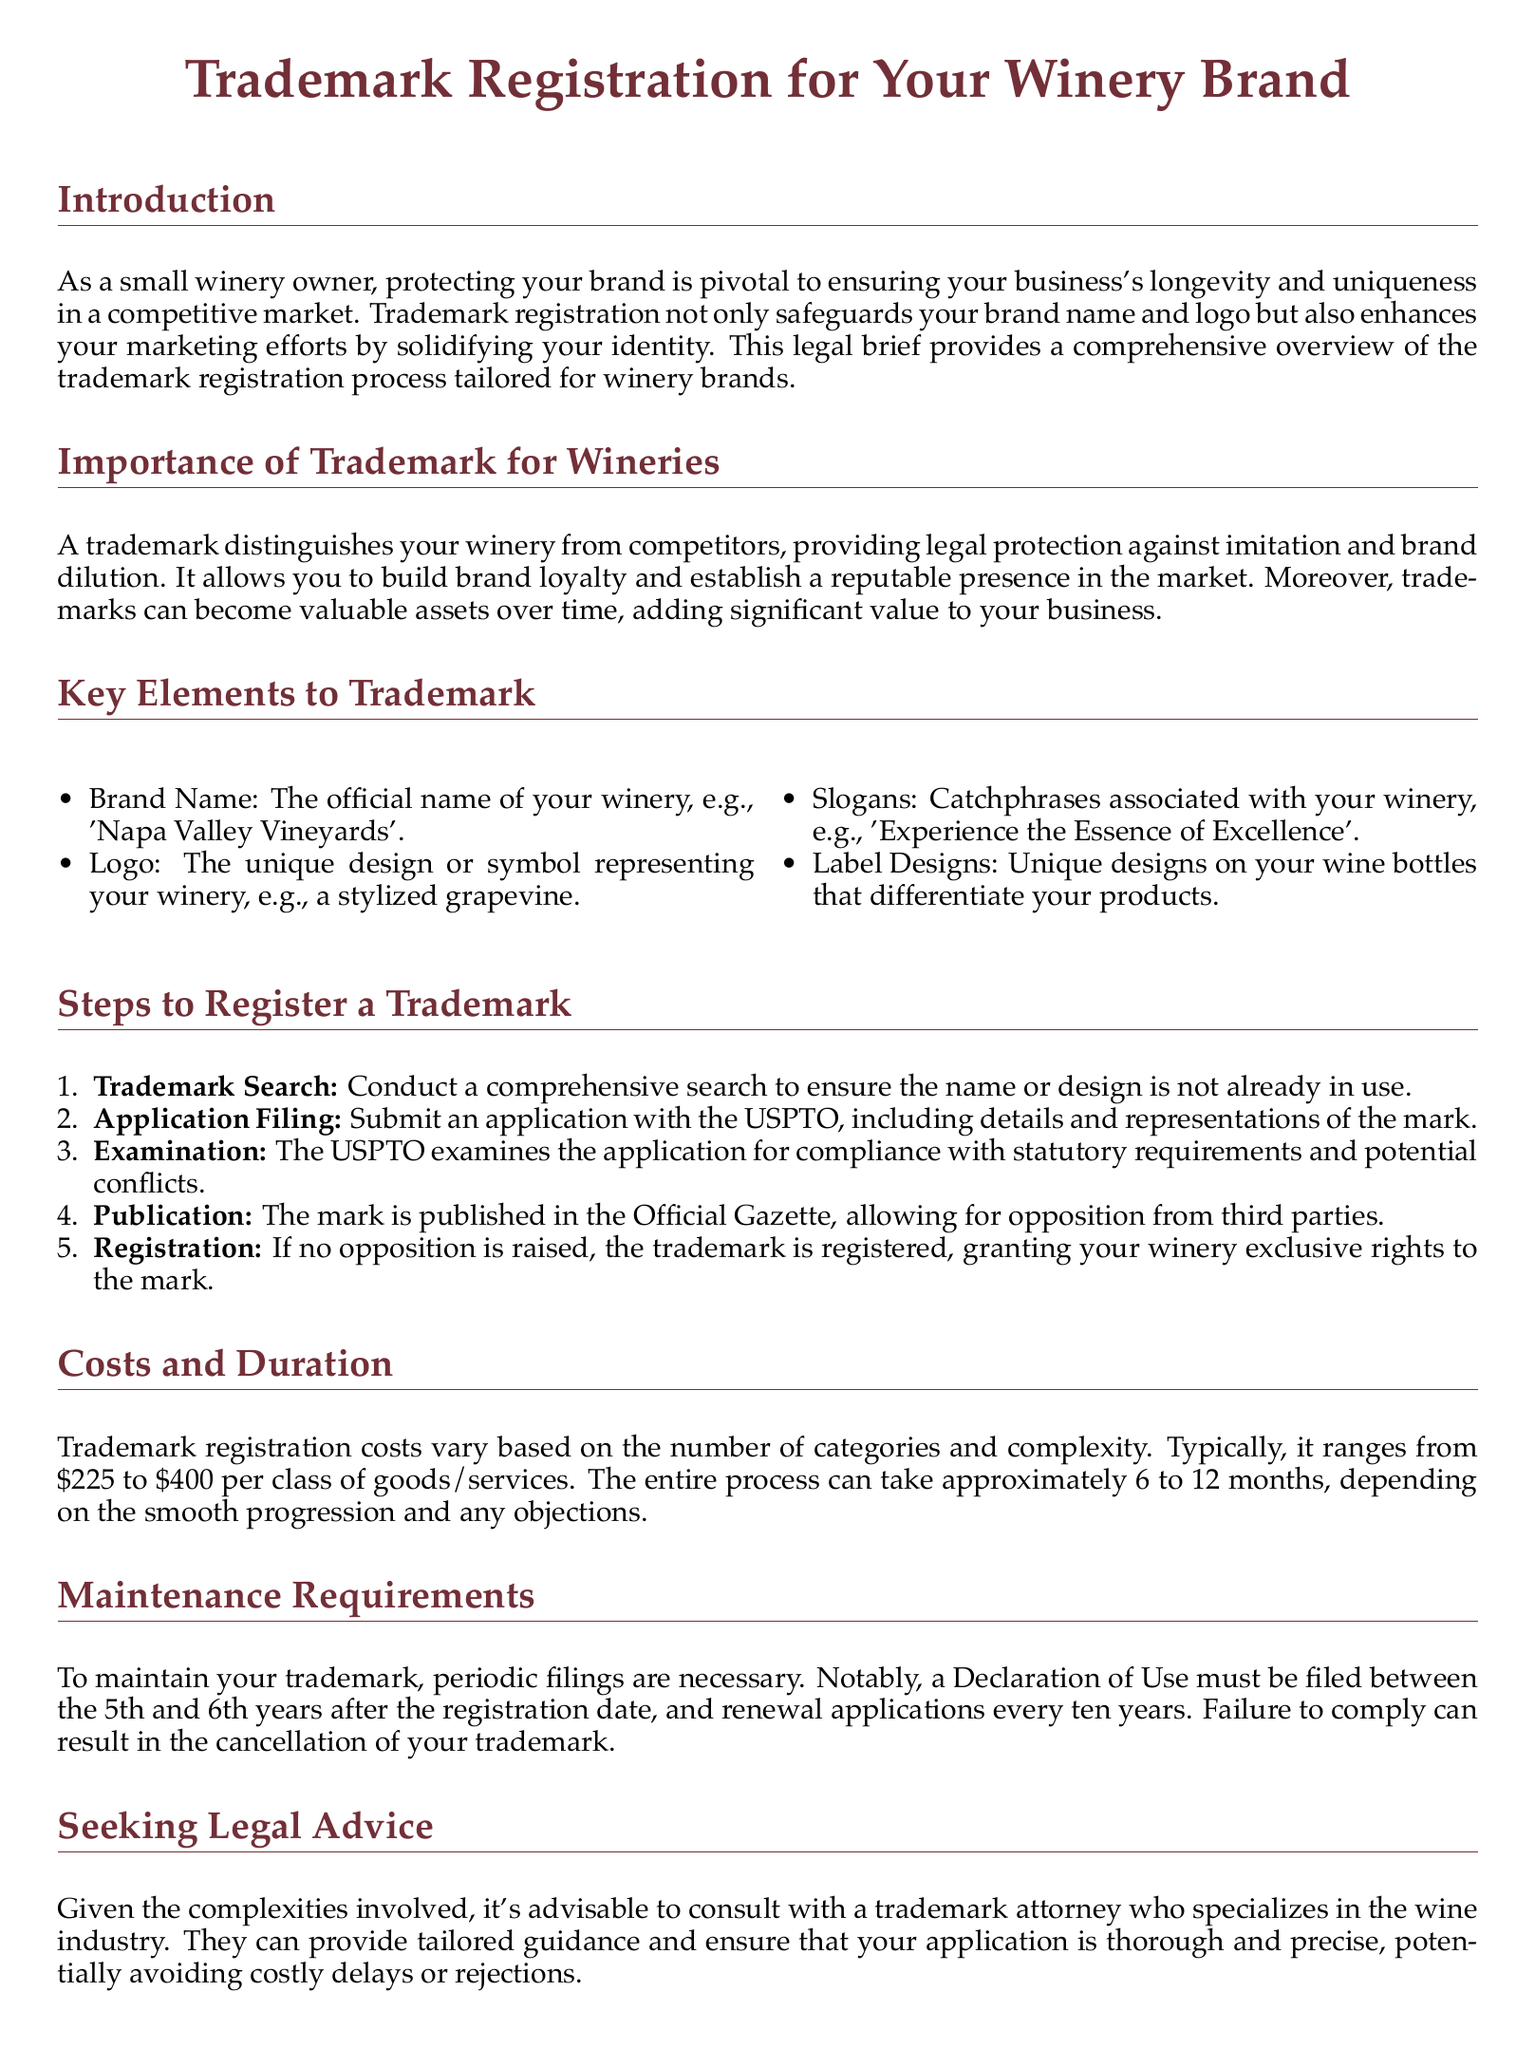What is the primary benefit of trademark registration for wineries? The primary benefit is safeguarding your brand name and logo, enhancing marketing efforts, and solidifying identity.
Answer: Safeguarding your brand What is the cost range for trademark registration? The document states that trademark registration costs typically range from $225 to $400 per class of goods/services.
Answer: $225 to $400 What must be submitted with the trademark application? The trademark application must include details and representations of the mark.
Answer: Details and representations How long does the trademark registration process typically take? The document indicates that the process can take approximately 6 to 12 months.
Answer: 6 to 12 months What is the first step in the trademark registration process? The first step is conducting a comprehensive trademark search.
Answer: Trademark Search How often must a renewal application be filed for a trademark? A renewal application must be filed every ten years.
Answer: Every ten years What document must be filed between the 5th and 6th years after registration? A Declaration of Use must be filed during this time.
Answer: Declaration of Use Why is it advisable to consult with a trademark attorney? Consulting with a trademark attorney is advisable due to the complexities involved and to avoid costly delays or rejections.
Answer: To avoid costly delays What type of assets can become valuable over time according to the document? Trademarks can become valuable assets over time.
Answer: Trademarks 